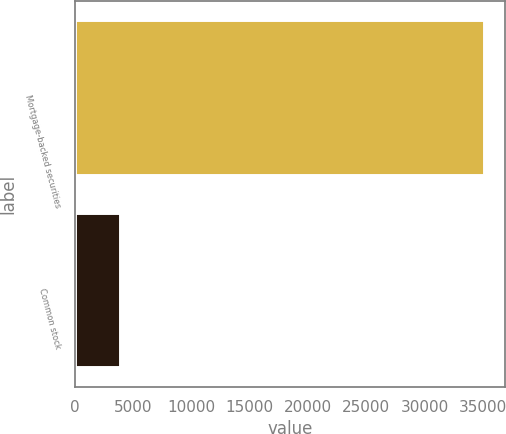Convert chart to OTSL. <chart><loc_0><loc_0><loc_500><loc_500><bar_chart><fcel>Mortgage-backed securities<fcel>Common stock<nl><fcel>35122<fcel>3845<nl></chart> 